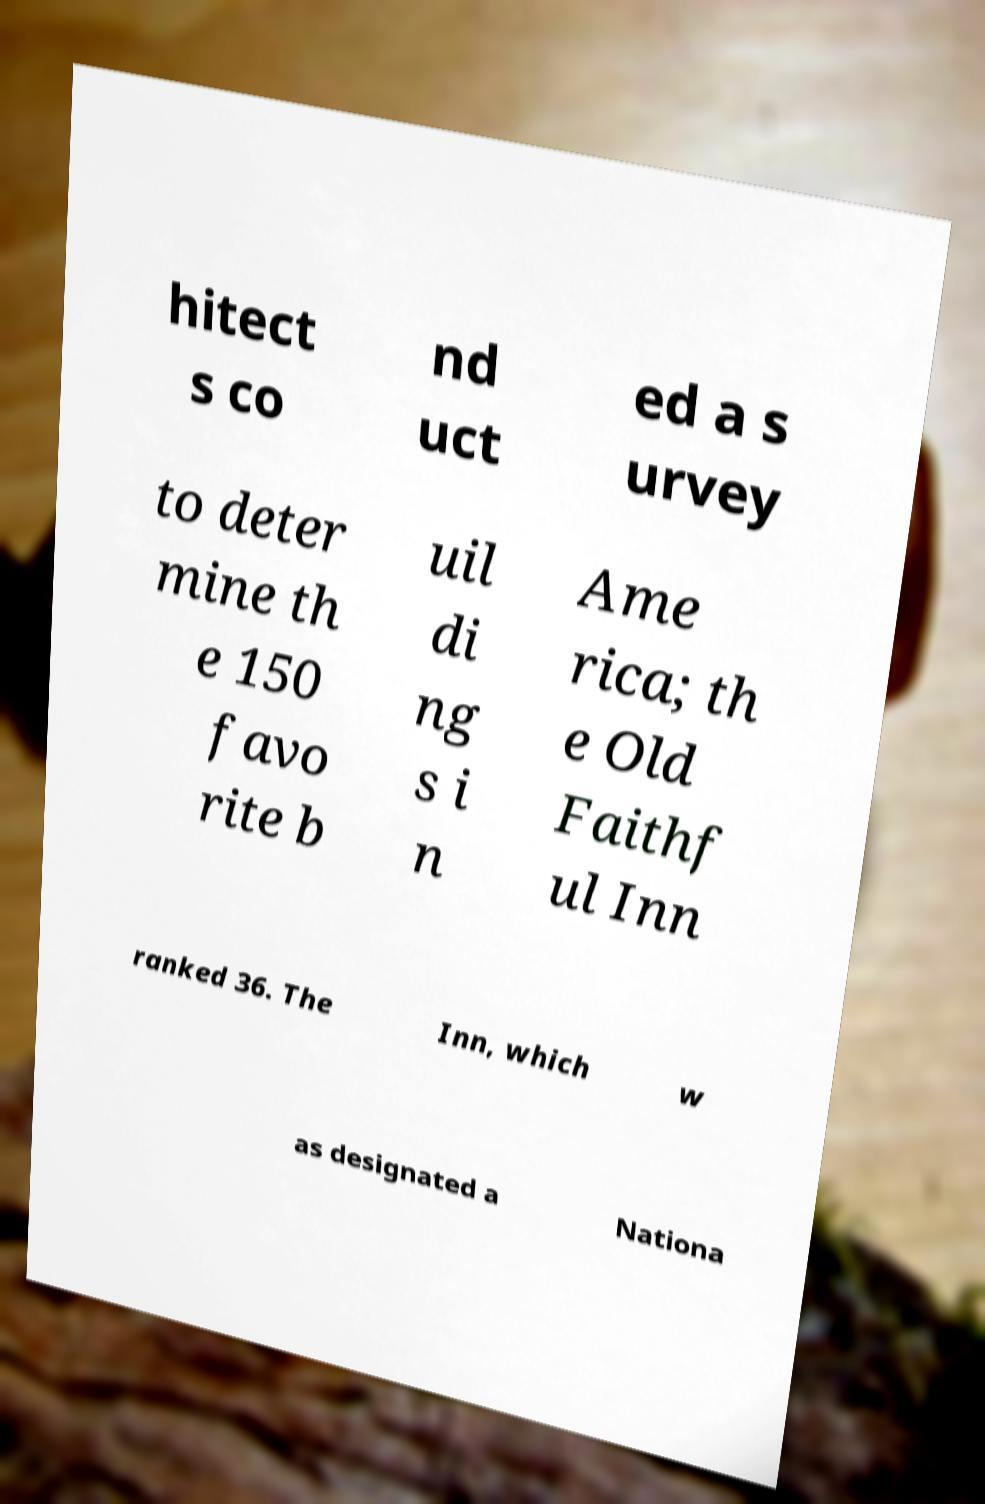Please identify and transcribe the text found in this image. hitect s co nd uct ed a s urvey to deter mine th e 150 favo rite b uil di ng s i n Ame rica; th e Old Faithf ul Inn ranked 36. The Inn, which w as designated a Nationa 